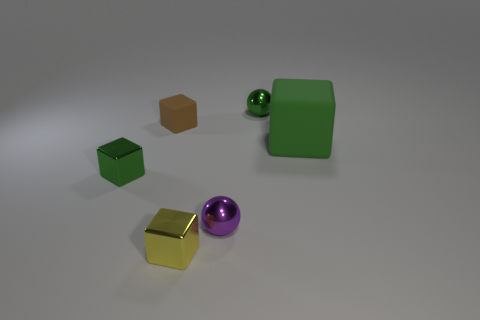Add 1 tiny rubber blocks. How many objects exist? 7 Subtract all blocks. How many objects are left? 2 Subtract 0 cyan cubes. How many objects are left? 6 Subtract all tiny yellow metal things. Subtract all brown objects. How many objects are left? 4 Add 3 brown rubber things. How many brown rubber things are left? 4 Add 4 big cyan objects. How many big cyan objects exist? 4 